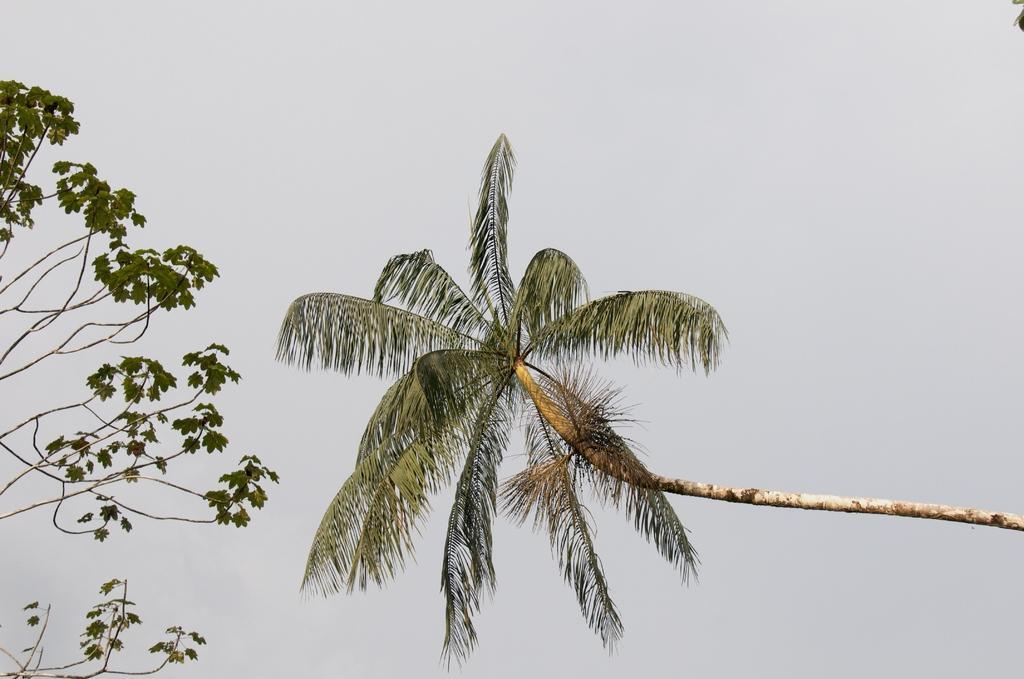How would you summarize this image in a sentence or two? In this image there are two trees as we can see in middle of this image and there is a sky in the background. 